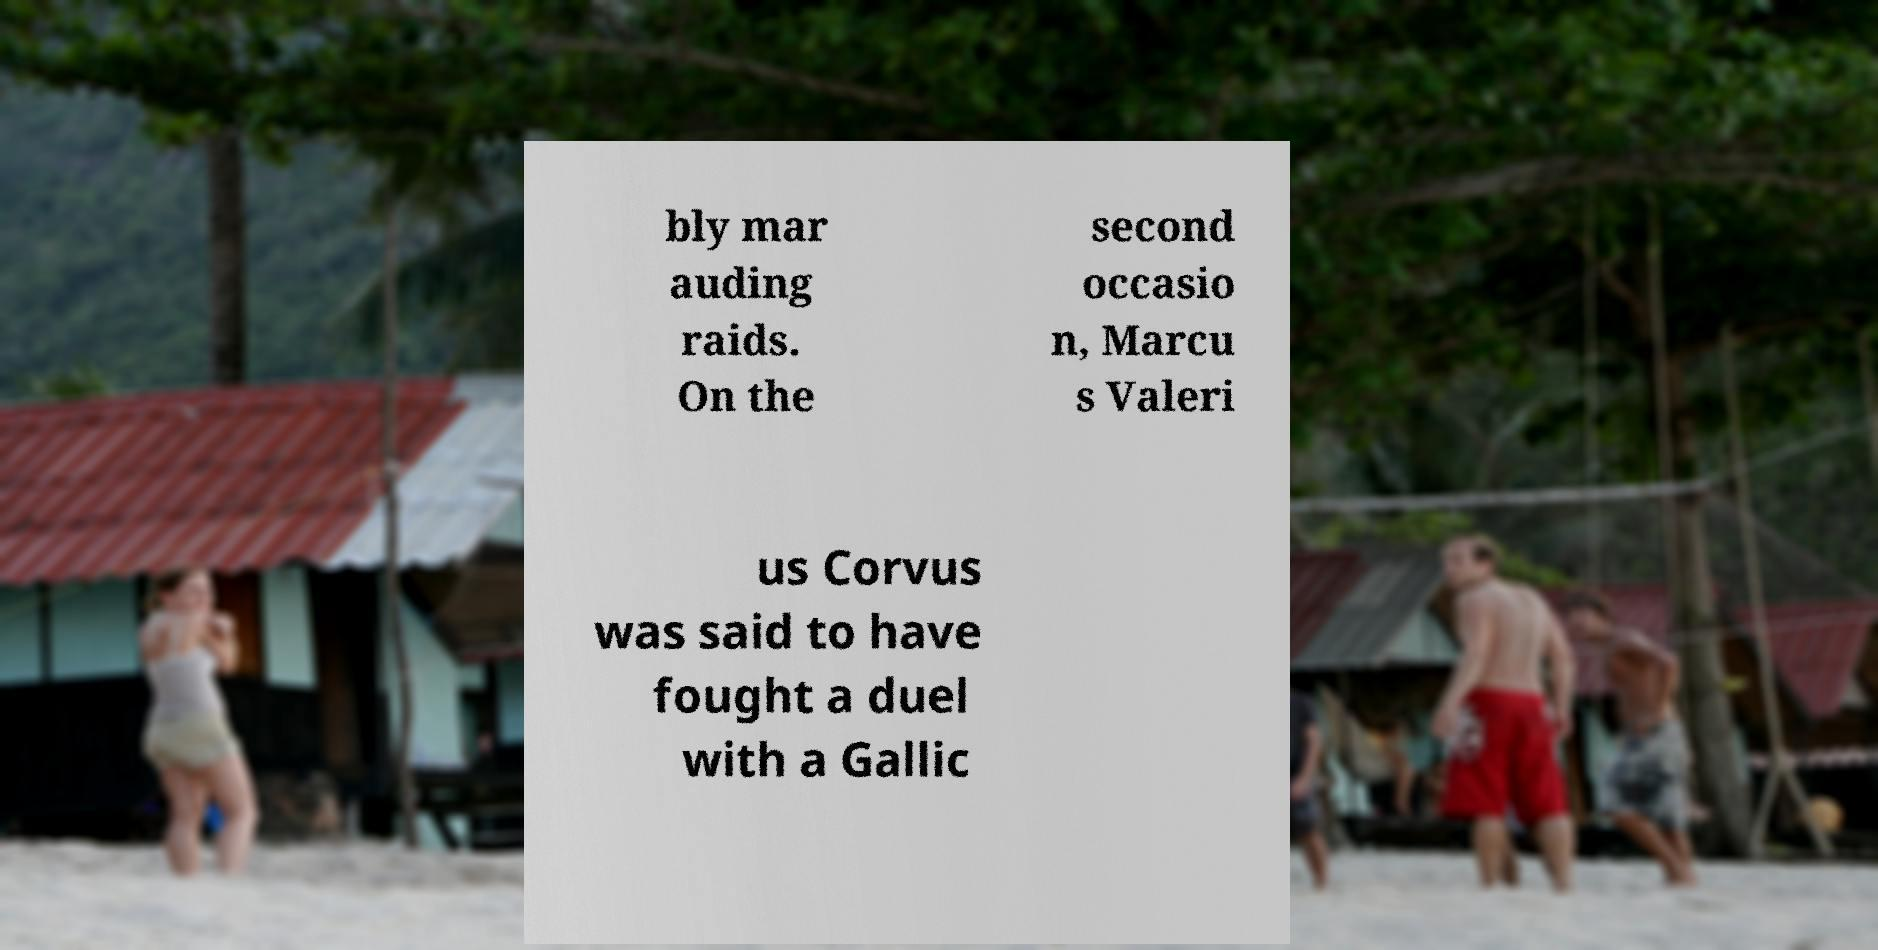I need the written content from this picture converted into text. Can you do that? bly mar auding raids. On the second occasio n, Marcu s Valeri us Corvus was said to have fought a duel with a Gallic 